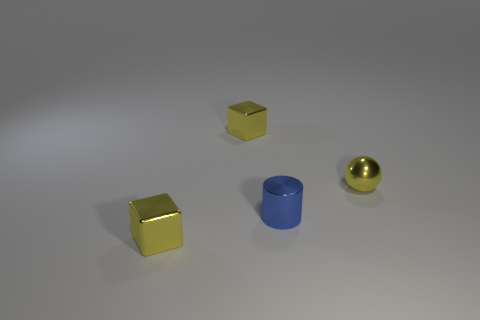What shape is the tiny yellow thing on the right side of the small yellow cube right of the tiny shiny cube that is in front of the cylinder?
Make the answer very short. Sphere. What is the material of the small block that is to the right of the yellow metallic thing that is in front of the small yellow ball?
Give a very brief answer. Metal. There is a tiny blue object that is the same material as the yellow ball; what is its shape?
Give a very brief answer. Cylinder. Are there any other things that are the same shape as the small blue metallic thing?
Your answer should be compact. No. How many tiny cubes are to the right of the blue object?
Give a very brief answer. 0. Are any green matte objects visible?
Your answer should be very brief. No. The block that is in front of the small cylinder that is on the left side of the shiny thing that is to the right of the blue metal thing is what color?
Give a very brief answer. Yellow. Is there a small metallic cylinder to the left of the yellow metal cube in front of the ball?
Ensure brevity in your answer.  No. There is a small cube behind the blue thing; is it the same color as the metal cylinder in front of the metallic ball?
Your answer should be compact. No. How many yellow shiny objects have the same size as the blue cylinder?
Make the answer very short. 3. 